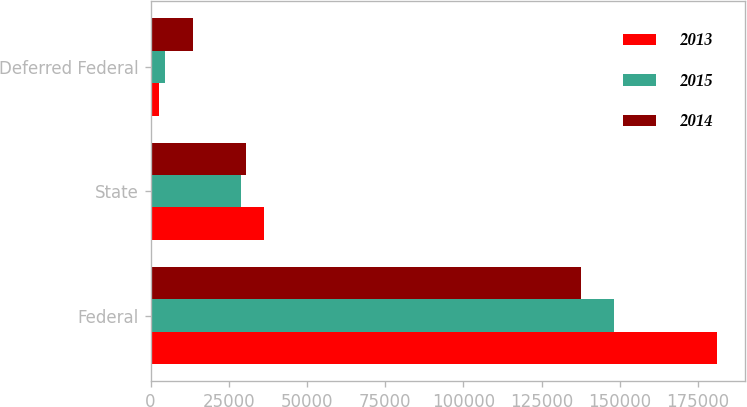Convert chart to OTSL. <chart><loc_0><loc_0><loc_500><loc_500><stacked_bar_chart><ecel><fcel>Federal<fcel>State<fcel>Deferred Federal<nl><fcel>2013<fcel>180895<fcel>36142<fcel>2681<nl><fcel>2015<fcel>148221<fcel>28881<fcel>4451<nl><fcel>2014<fcel>137675<fcel>30352<fcel>13402<nl></chart> 